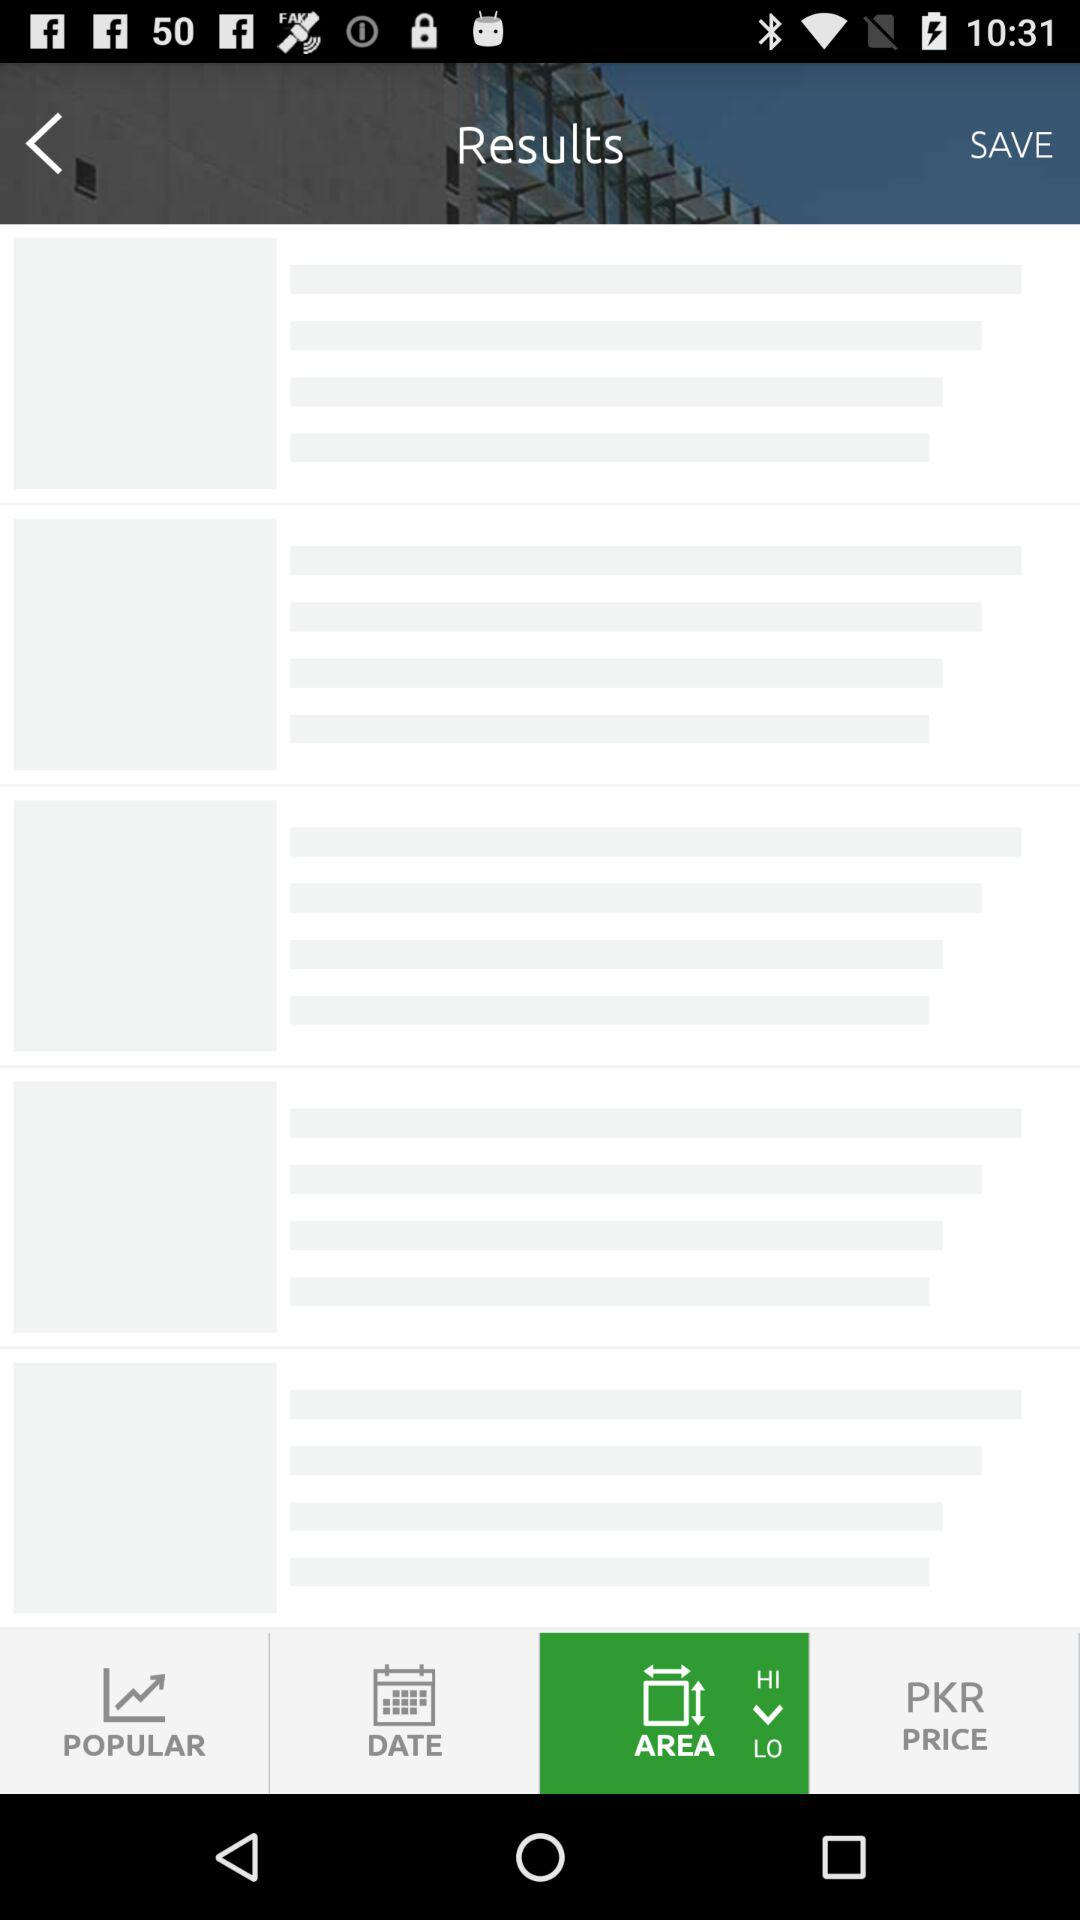Which account can I use to log in? You can log in with "FACEBOOK" and "Email". 